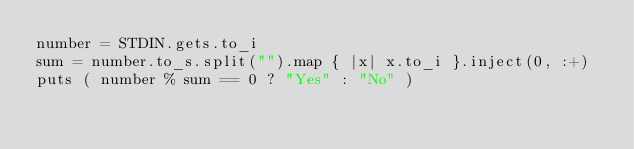Convert code to text. <code><loc_0><loc_0><loc_500><loc_500><_Ruby_>number = STDIN.gets.to_i
sum = number.to_s.split("").map { |x| x.to_i }.inject(0, :+)
puts ( number % sum == 0 ? "Yes" : "No" )

</code> 